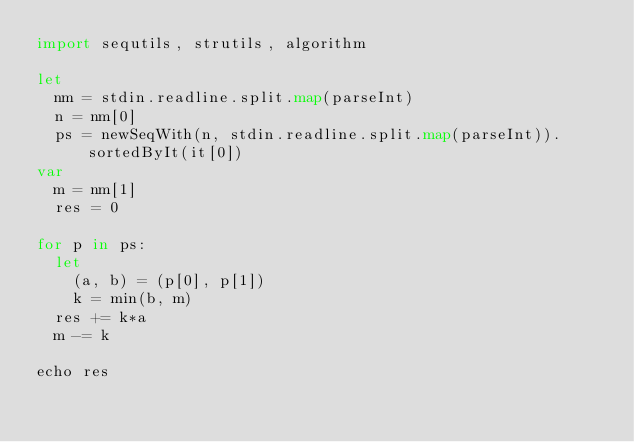Convert code to text. <code><loc_0><loc_0><loc_500><loc_500><_Nim_>import sequtils, strutils, algorithm

let
  nm = stdin.readline.split.map(parseInt)
  n = nm[0]
  ps = newSeqWith(n, stdin.readline.split.map(parseInt)).sortedByIt(it[0])
var
  m = nm[1]
  res = 0

for p in ps:
  let
    (a, b) = (p[0], p[1])
    k = min(b, m)
  res += k*a
  m -= k

echo res
</code> 